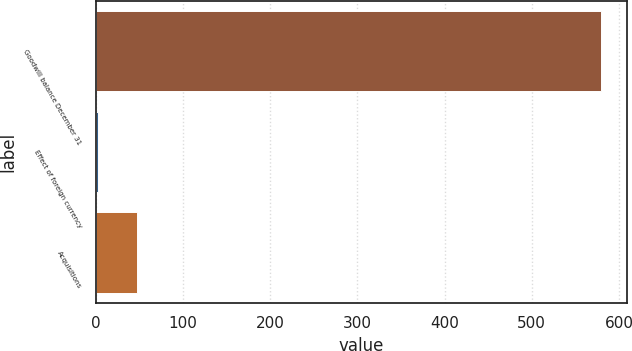<chart> <loc_0><loc_0><loc_500><loc_500><bar_chart><fcel>Goodwill balance December 31<fcel>Effect of foreign currency<fcel>Acquisitions<nl><fcel>579.66<fcel>2.81<fcel>48.03<nl></chart> 